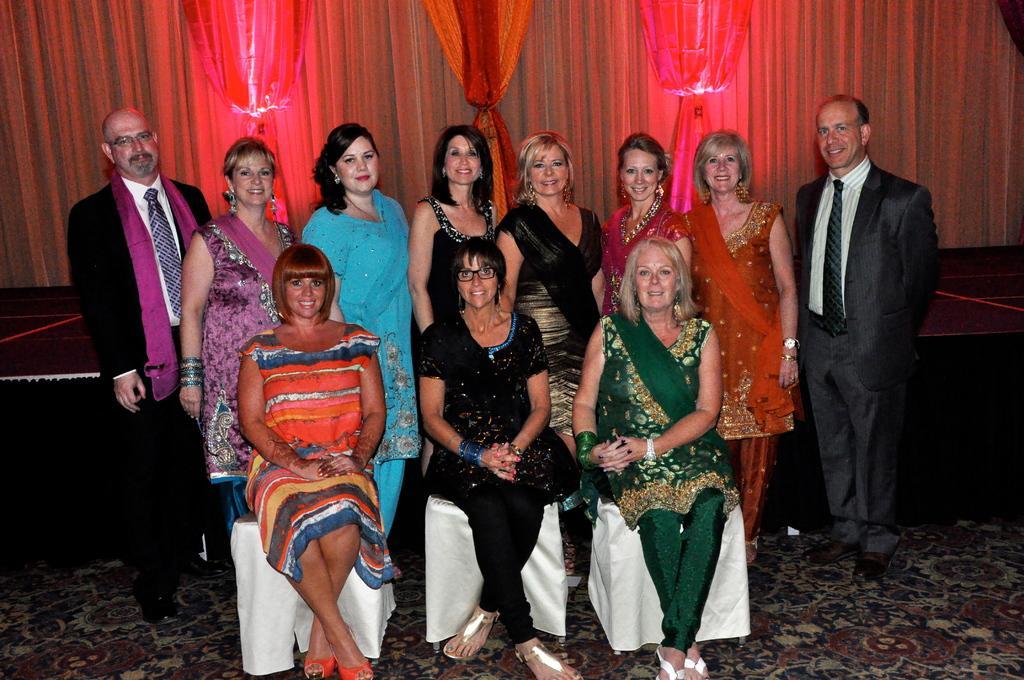Describe this image in one or two sentences. In this image there are group of persons sitting and standing and smiling. In the background there are curtains which are red in colour. 